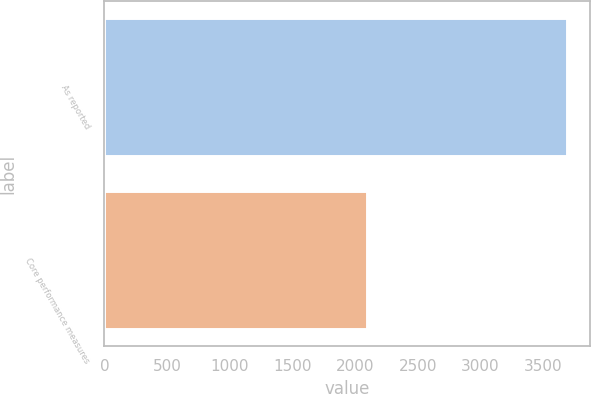Convert chart. <chart><loc_0><loc_0><loc_500><loc_500><bar_chart><fcel>As reported<fcel>Core performance measures<nl><fcel>3692<fcel>2096<nl></chart> 